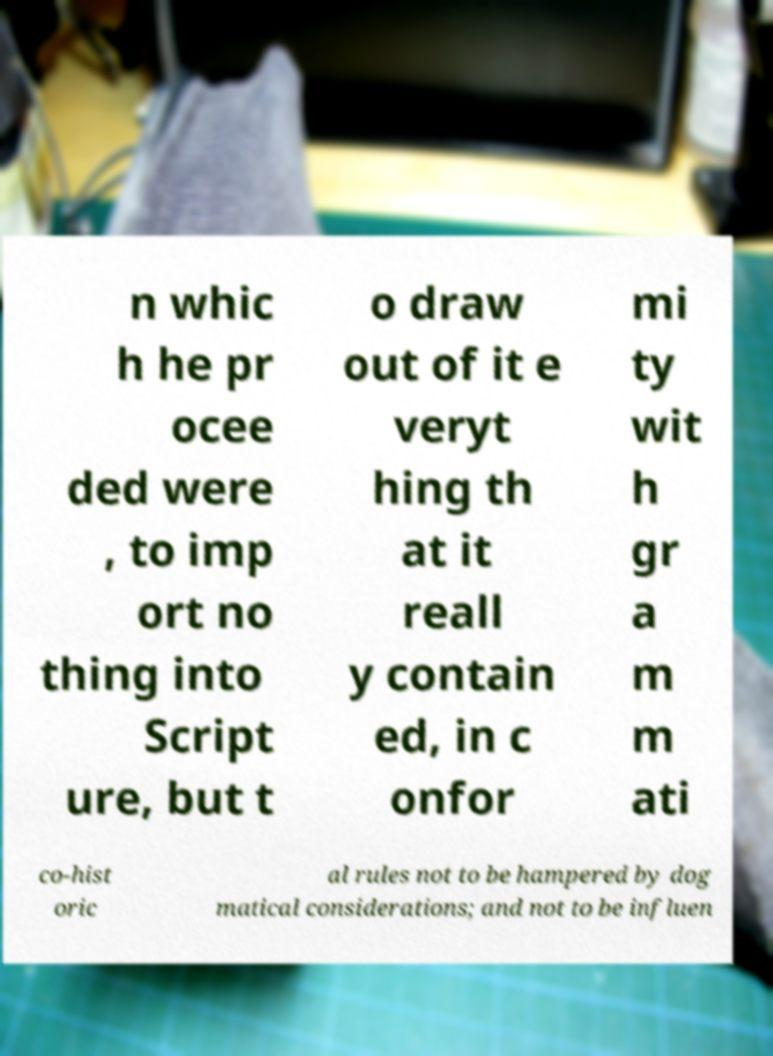I need the written content from this picture converted into text. Can you do that? n whic h he pr ocee ded were , to imp ort no thing into Script ure, but t o draw out of it e veryt hing th at it reall y contain ed, in c onfor mi ty wit h gr a m m ati co-hist oric al rules not to be hampered by dog matical considerations; and not to be influen 